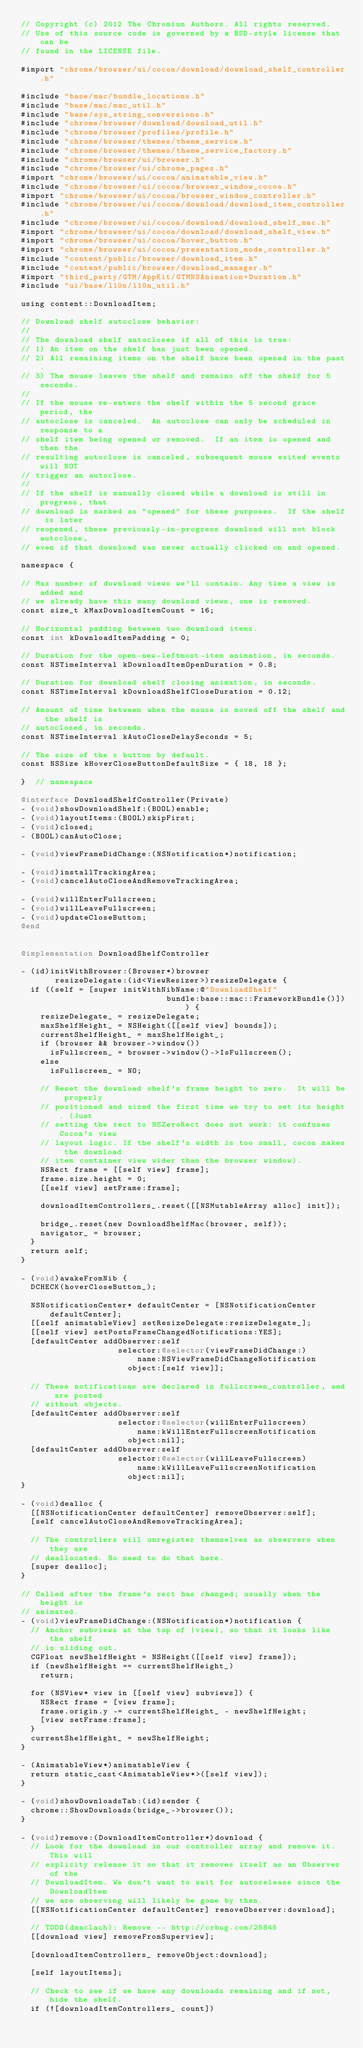<code> <loc_0><loc_0><loc_500><loc_500><_ObjectiveC_>// Copyright (c) 2012 The Chromium Authors. All rights reserved.
// Use of this source code is governed by a BSD-style license that can be
// found in the LICENSE file.

#import "chrome/browser/ui/cocoa/download/download_shelf_controller.h"

#include "base/mac/bundle_locations.h"
#include "base/mac/mac_util.h"
#include "base/sys_string_conversions.h"
#include "chrome/browser/download/download_util.h"
#include "chrome/browser/profiles/profile.h"
#include "chrome/browser/themes/theme_service.h"
#include "chrome/browser/themes/theme_service_factory.h"
#include "chrome/browser/ui/browser.h"
#include "chrome/browser/ui/chrome_pages.h"
#import "chrome/browser/ui/cocoa/animatable_view.h"
#include "chrome/browser/ui/cocoa/browser_window_cocoa.h"
#import "chrome/browser/ui/cocoa/browser_window_controller.h"
#include "chrome/browser/ui/cocoa/download/download_item_controller.h"
#include "chrome/browser/ui/cocoa/download/download_shelf_mac.h"
#import "chrome/browser/ui/cocoa/download/download_shelf_view.h"
#import "chrome/browser/ui/cocoa/hover_button.h"
#import "chrome/browser/ui/cocoa/presentation_mode_controller.h"
#include "content/public/browser/download_item.h"
#include "content/public/browser/download_manager.h"
#import "third_party/GTM/AppKit/GTMNSAnimation+Duration.h"
#include "ui/base/l10n/l10n_util.h"

using content::DownloadItem;

// Download shelf autoclose behavior:
//
// The download shelf autocloses if all of this is true:
// 1) An item on the shelf has just been opened.
// 2) All remaining items on the shelf have been opened in the past.
// 3) The mouse leaves the shelf and remains off the shelf for 5 seconds.
//
// If the mouse re-enters the shelf within the 5 second grace period, the
// autoclose is canceled.  An autoclose can only be scheduled in response to a
// shelf item being opened or removed.  If an item is opened and then the
// resulting autoclose is canceled, subsequent mouse exited events will NOT
// trigger an autoclose.
//
// If the shelf is manually closed while a download is still in progress, that
// download is marked as "opened" for these purposes.  If the shelf is later
// reopened, these previously-in-progress download will not block autoclose,
// even if that download was never actually clicked on and opened.

namespace {

// Max number of download views we'll contain. Any time a view is added and
// we already have this many download views, one is removed.
const size_t kMaxDownloadItemCount = 16;

// Horizontal padding between two download items.
const int kDownloadItemPadding = 0;

// Duration for the open-new-leftmost-item animation, in seconds.
const NSTimeInterval kDownloadItemOpenDuration = 0.8;

// Duration for download shelf closing animation, in seconds.
const NSTimeInterval kDownloadShelfCloseDuration = 0.12;

// Amount of time between when the mouse is moved off the shelf and the shelf is
// autoclosed, in seconds.
const NSTimeInterval kAutoCloseDelaySeconds = 5;

// The size of the x button by default.
const NSSize kHoverCloseButtonDefaultSize = { 18, 18 };

}  // namespace

@interface DownloadShelfController(Private)
- (void)showDownloadShelf:(BOOL)enable;
- (void)layoutItems:(BOOL)skipFirst;
- (void)closed;
- (BOOL)canAutoClose;

- (void)viewFrameDidChange:(NSNotification*)notification;

- (void)installTrackingArea;
- (void)cancelAutoCloseAndRemoveTrackingArea;

- (void)willEnterFullscreen;
- (void)willLeaveFullscreen;
- (void)updateCloseButton;
@end


@implementation DownloadShelfController

- (id)initWithBrowser:(Browser*)browser
       resizeDelegate:(id<ViewResizer>)resizeDelegate {
  if ((self = [super initWithNibName:@"DownloadShelf"
                              bundle:base::mac::FrameworkBundle()])) {
    resizeDelegate_ = resizeDelegate;
    maxShelfHeight_ = NSHeight([[self view] bounds]);
    currentShelfHeight_ = maxShelfHeight_;
    if (browser && browser->window())
      isFullscreen_ = browser->window()->IsFullscreen();
    else
      isFullscreen_ = NO;

    // Reset the download shelf's frame height to zero.  It will be properly
    // positioned and sized the first time we try to set its height. (Just
    // setting the rect to NSZeroRect does not work: it confuses Cocoa's view
    // layout logic. If the shelf's width is too small, cocoa makes the download
    // item container view wider than the browser window).
    NSRect frame = [[self view] frame];
    frame.size.height = 0;
    [[self view] setFrame:frame];

    downloadItemControllers_.reset([[NSMutableArray alloc] init]);

    bridge_.reset(new DownloadShelfMac(browser, self));
    navigator_ = browser;
  }
  return self;
}

- (void)awakeFromNib {
  DCHECK(hoverCloseButton_);

  NSNotificationCenter* defaultCenter = [NSNotificationCenter defaultCenter];
  [[self animatableView] setResizeDelegate:resizeDelegate_];
  [[self view] setPostsFrameChangedNotifications:YES];
  [defaultCenter addObserver:self
                    selector:@selector(viewFrameDidChange:)
                        name:NSViewFrameDidChangeNotification
                      object:[self view]];

  // These notifications are declared in fullscreen_controller, and are posted
  // without objects.
  [defaultCenter addObserver:self
                    selector:@selector(willEnterFullscreen)
                        name:kWillEnterFullscreenNotification
                      object:nil];
  [defaultCenter addObserver:self
                    selector:@selector(willLeaveFullscreen)
                        name:kWillLeaveFullscreenNotification
                      object:nil];
}

- (void)dealloc {
  [[NSNotificationCenter defaultCenter] removeObserver:self];
  [self cancelAutoCloseAndRemoveTrackingArea];

  // The controllers will unregister themselves as observers when they are
  // deallocated. No need to do that here.
  [super dealloc];
}

// Called after the frame's rect has changed; usually when the height is
// animated.
- (void)viewFrameDidChange:(NSNotification*)notification {
  // Anchor subviews at the top of |view|, so that it looks like the shelf
  // is sliding out.
  CGFloat newShelfHeight = NSHeight([[self view] frame]);
  if (newShelfHeight == currentShelfHeight_)
    return;

  for (NSView* view in [[self view] subviews]) {
    NSRect frame = [view frame];
    frame.origin.y -= currentShelfHeight_ - newShelfHeight;
    [view setFrame:frame];
  }
  currentShelfHeight_ = newShelfHeight;
}

- (AnimatableView*)animatableView {
  return static_cast<AnimatableView*>([self view]);
}

- (void)showDownloadsTab:(id)sender {
  chrome::ShowDownloads(bridge_->browser());
}

- (void)remove:(DownloadItemController*)download {
  // Look for the download in our controller array and remove it. This will
  // explicity release it so that it removes itself as an Observer of the
  // DownloadItem. We don't want to wait for autorelease since the DownloadItem
  // we are observing will likely be gone by then.
  [[NSNotificationCenter defaultCenter] removeObserver:download];

  // TODO(dmaclach): Remove -- http://crbug.com/25845
  [[download view] removeFromSuperview];

  [downloadItemControllers_ removeObject:download];

  [self layoutItems];

  // Check to see if we have any downloads remaining and if not, hide the shelf.
  if (![downloadItemControllers_ count])</code> 